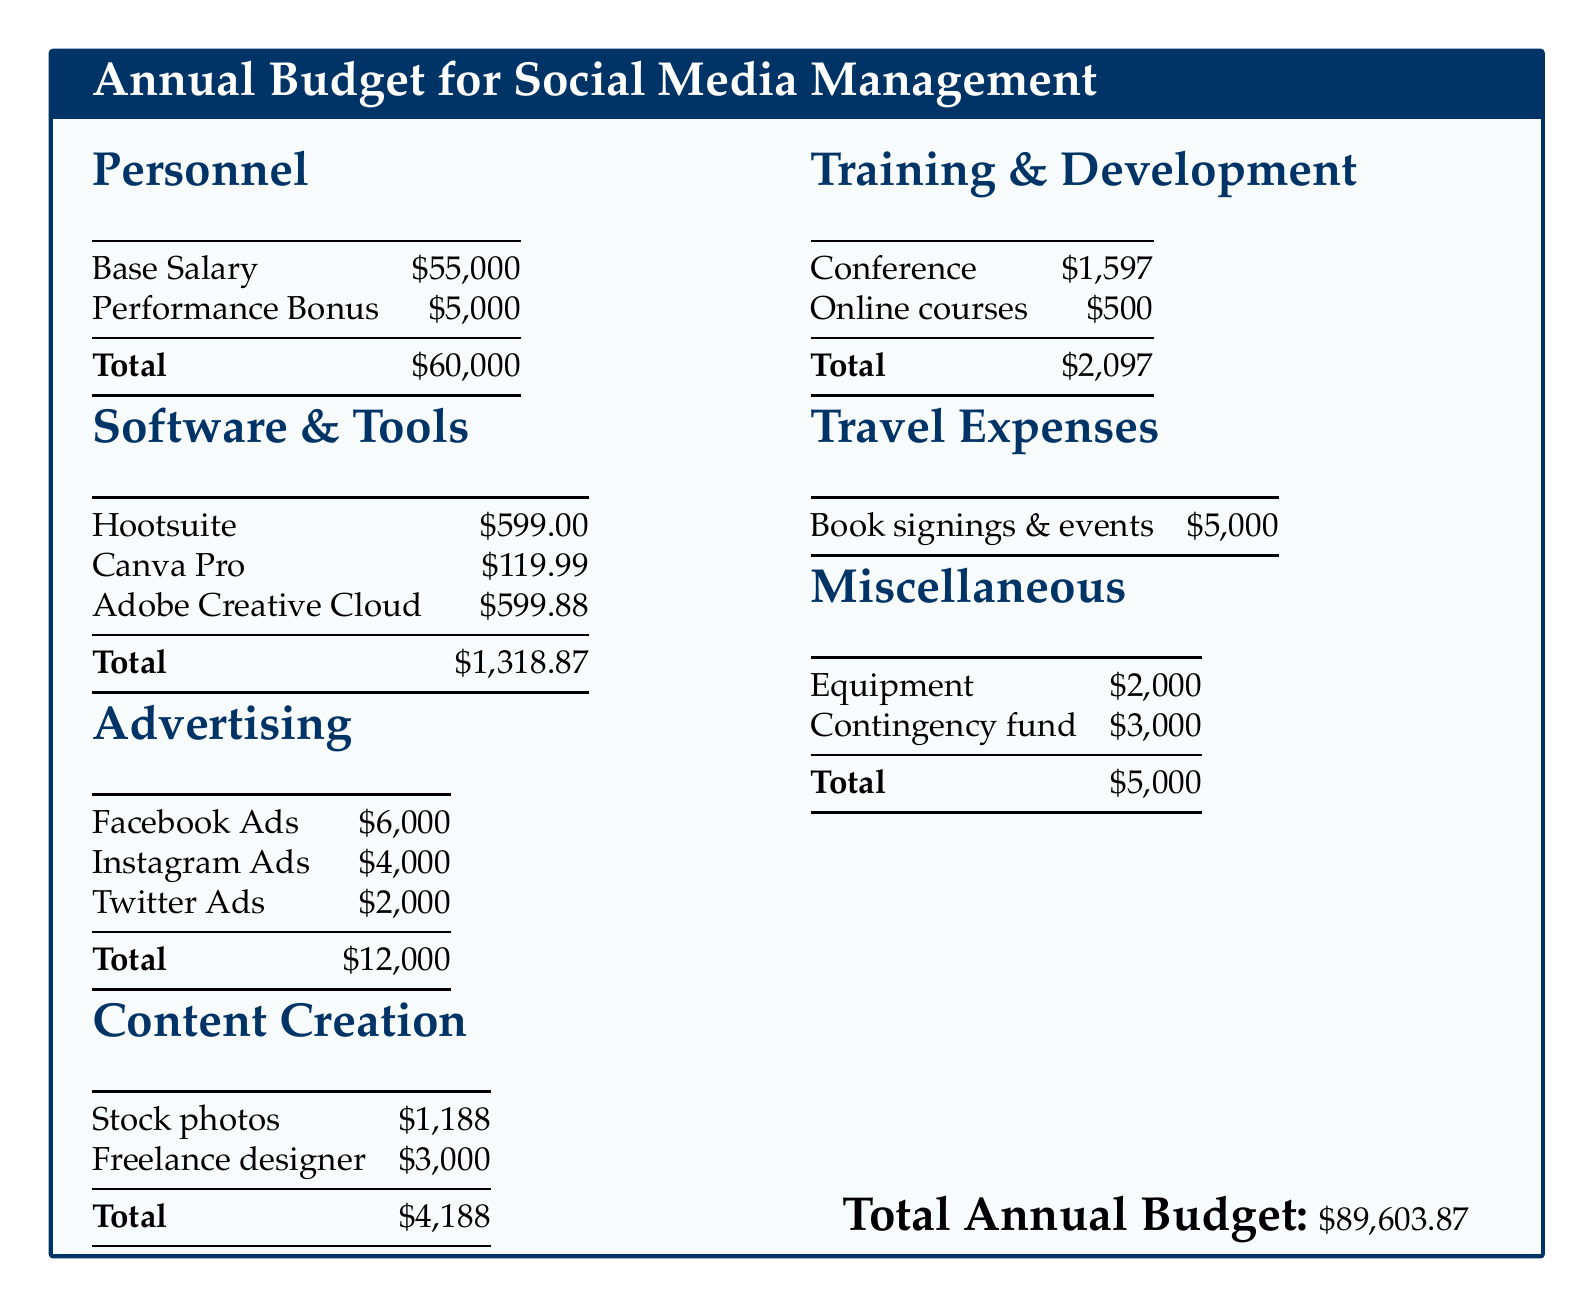What is the base salary for the social media manager? The base salary is listed in the personnel section of the document as $55,000.
Answer: $55,000 What is the total amount allocated for software and tools? The total for software and tools is calculated from the itemized costs in that section, which sums to $1,318.87.
Answer: $1,318.87 How much is allocated for Facebook Ads? The document specifies that $6,000 is allocated for Facebook Ads in the advertising section.
Answer: $6,000 What is the total budget for training and development? The total for training and development is the combined costs for the conference and online courses, amounting to $2,097.
Answer: $2,097 What are the total travel expenses? The travel expenses consist of a single line item for book signings and events, which is $5,000.
Answer: $5,000 What is the total annual budget? The total annual budget is concluded at the end of the document, stated as $89,603.87.
Answer: $89,603.87 Which software costs the most? The document highlights Adobe Creative Cloud as the most expensive software tool at $599.88.
Answer: Adobe Creative Cloud What is the budget for content creation? The content creation budget consists of stock photos and freelance designer costs, totaling $4,188.
Answer: $4,188 How much is set aside for the contingency fund? The contingency fund in the miscellaneous section is specified as $3,000.
Answer: $3,000 